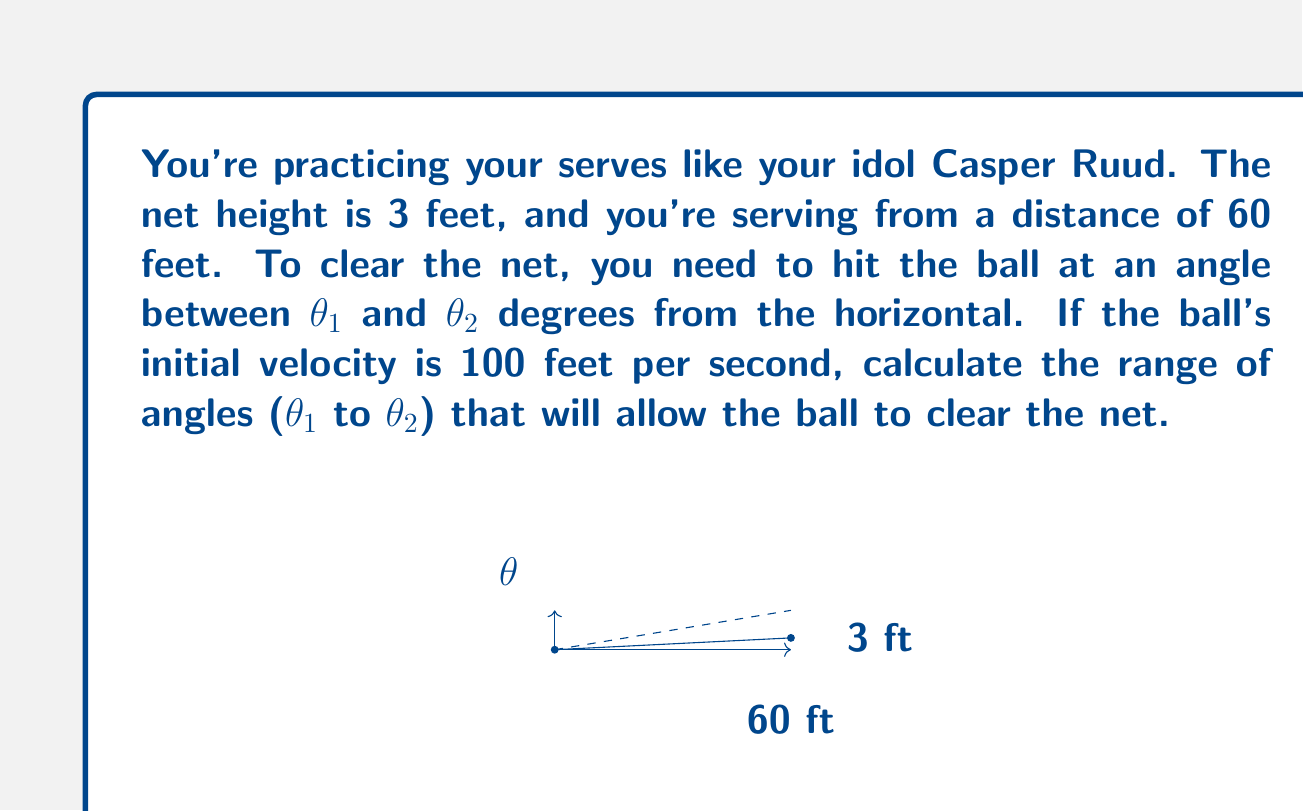Solve this math problem. Let's approach this step-by-step:

1) We can use the equation of projectile motion:

   $$y = x \tan\theta - \frac{gx^2}{2v^2\cos^2\theta}$$

   where $y$ is the height, $x$ is the horizontal distance, $\theta$ is the angle, $g$ is gravity (32 ft/s²), and $v$ is initial velocity.

2) At the net, we know $x = 60$ ft and $y = 3$ ft. Substituting these and the given $v = 100$ ft/s:

   $$3 = 60 \tan\theta - \frac{32(60)^2}{2(100)^2\cos^2\theta}$$

3) Simplify:

   $$3 = 60 \tan\theta - 5.76\sec^2\theta$$

4) Rearrange:

   $$60 \tan\theta - 5.76\sec^2\theta - 3 = 0$$

5) This is a transcendental equation. We can solve it numerically to find $\theta_1$ and $\theta_2$.

6) Using a numerical solver, we find:
   $\theta_1 \approx 2.87°$ and $\theta_2 \approx 7.20°$

These angles represent the minimum and maximum angles that will allow the ball to just clear the net.
Answer: $2.87° \leq \theta \leq 7.20°$ 